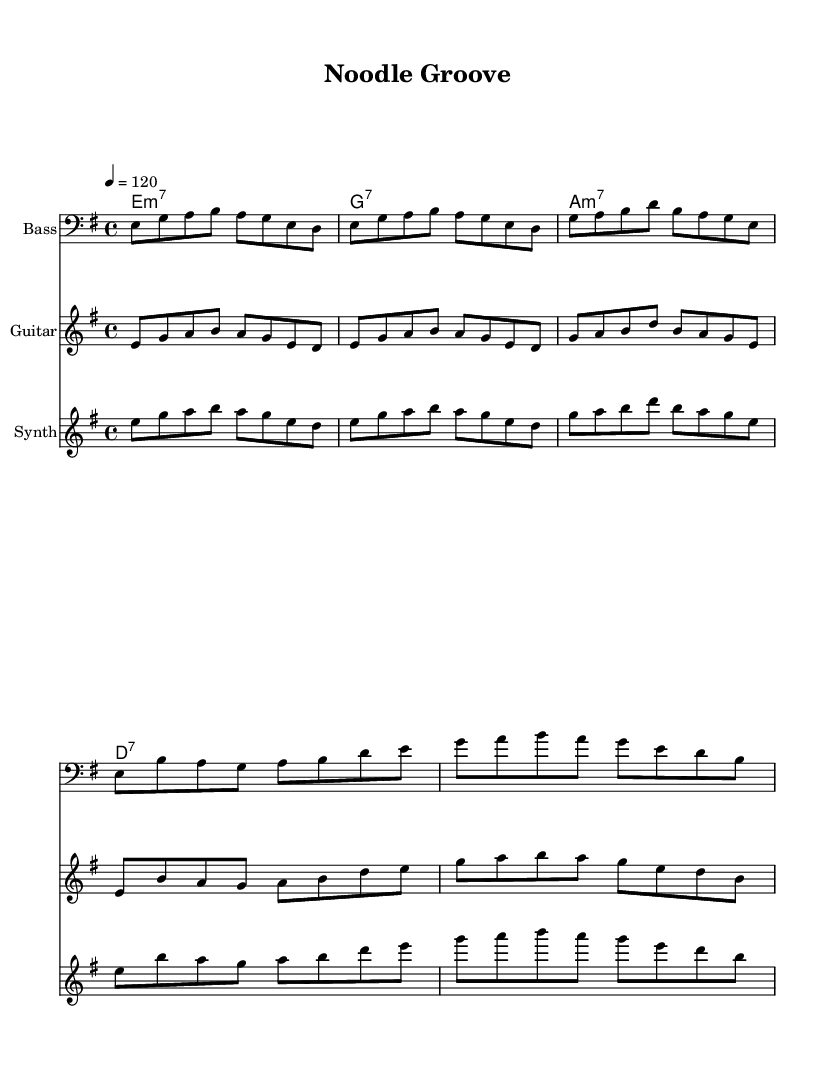What is the key signature of this music? The key signature indicates E minor, which has one sharp (F#). This can be deduced from the global settings that define the music's key.
Answer: E minor What is the time signature of this music? The time signature is found in the global settings section, showing a 4/4 meter, which means there are four beats per measure and the quarter note gets one beat.
Answer: 4/4 What is the tempo marking in this music? The tempo marking is located in the global settings, showing the tempo is set at 120 beats per minute. This means the music should be played at a moderate speed.
Answer: 120 How many measures are in the main riff section? By analyzing the provided musical sections, the main riff consists of two measures, as indicated by the repeated patterns that are clearly delineated.
Answer: 2 What type of seventh chord is used at the start? The chord names section states that the first chord is E minor 7 (e1:m7), which is articulated in the chord structure. This can be identified by the m7 suffix.
Answer: minor 7 Which instrument is playing the highest pitch in the chorus? In the chorus section, the instrument with the highest pitch will be the synthesizer, as its notes ascend compared to the bass and guitar parts. This observation arises from a visual analysis of the staff lines and note placement.
Answer: Synthesizer 